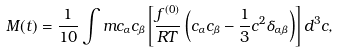Convert formula to latex. <formula><loc_0><loc_0><loc_500><loc_500>M ( t ) = \frac { 1 } { 1 0 } \int m c _ { \alpha } c _ { \beta } \left [ \frac { f ^ { ( 0 ) } } { R T } \left ( c _ { \alpha } c _ { \beta } - \frac { 1 } { 3 } c ^ { 2 } \delta _ { \alpha \beta } \right ) \right ] d ^ { 3 } c ,</formula> 